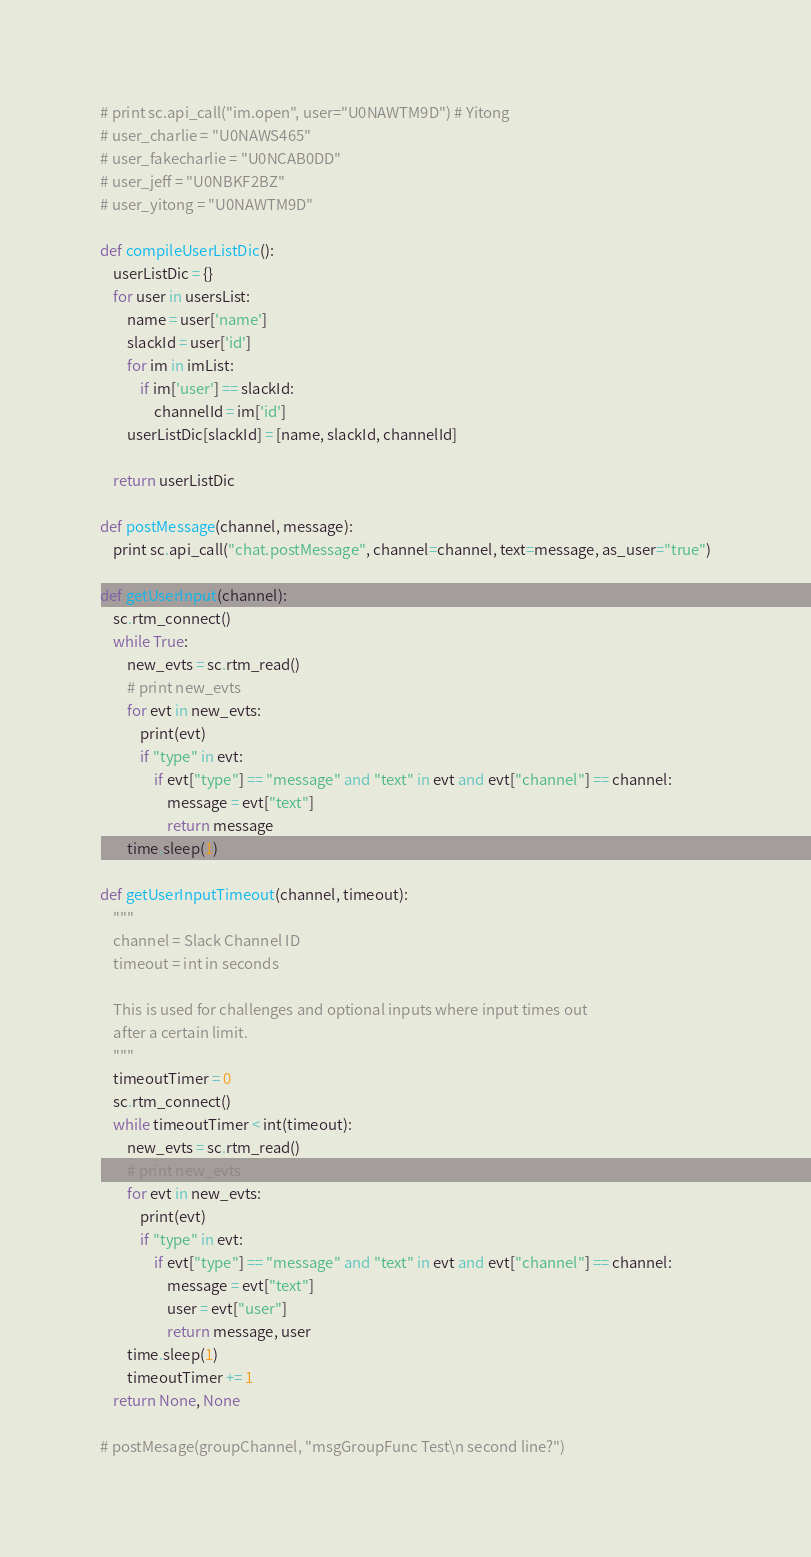<code> <loc_0><loc_0><loc_500><loc_500><_Python_># print sc.api_call("im.open", user="U0NAWTM9D") # Yitong
# user_charlie = "U0NAWS465"
# user_fakecharlie = "U0NCAB0DD"
# user_jeff = "U0NBKF2BZ"
# user_yitong = "U0NAWTM9D"

def compileUserListDic():
	userListDic = {}
	for user in usersList:
		name = user['name']
		slackId = user['id']
		for im in imList:
			if im['user'] == slackId:
				channelId = im['id']
		userListDic[slackId] = [name, slackId, channelId]

	return userListDic

def postMessage(channel, message):
	print sc.api_call("chat.postMessage", channel=channel, text=message, as_user="true")

def getUserInput(channel):
	sc.rtm_connect()
	while True:
	    new_evts = sc.rtm_read()
	    # print new_evts
	    for evt in new_evts:
	        print(evt)
	        if "type" in evt:
	            if evt["type"] == "message" and "text" in evt and evt["channel"] == channel:
	                message = evt["text"]
	                return message
	    time.sleep(1)

def getUserInputTimeout(channel, timeout):
	"""
	channel = Slack Channel ID
	timeout = int in seconds

	This is used for challenges and optional inputs where input times out 
	after a certain limit. 
	"""
	timeoutTimer = 0
	sc.rtm_connect()
	while timeoutTimer < int(timeout):
	    new_evts = sc.rtm_read()
	    # print new_evts
	    for evt in new_evts:
	        print(evt)
	        if "type" in evt:
	            if evt["type"] == "message" and "text" in evt and evt["channel"] == channel:
	                message = evt["text"]
	                user = evt["user"]
	                return message, user
	    time.sleep(1)
	    timeoutTimer += 1
	return None, None

# postMesage(groupChannel, "msgGroupFunc Test\n second line?")</code> 